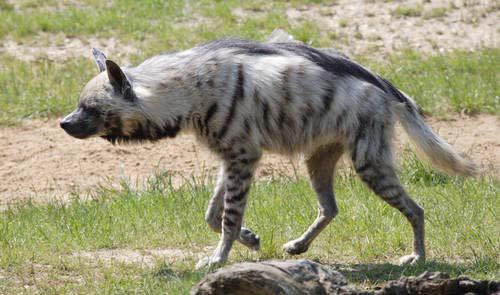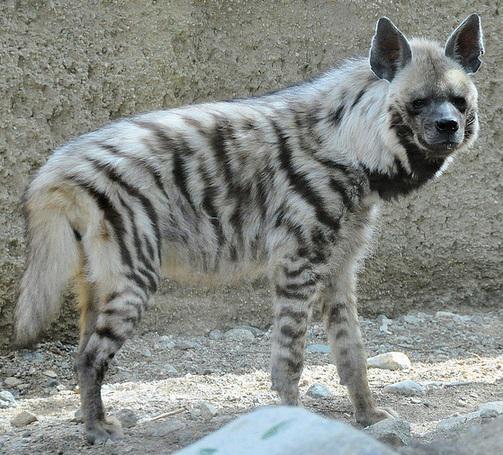The first image is the image on the left, the second image is the image on the right. Examine the images to the left and right. Is the description "Two hyenas are standing and facing opposite each other." accurate? Answer yes or no. Yes. The first image is the image on the left, the second image is the image on the right. Given the left and right images, does the statement "1 dog has a paw that is not touching the ground." hold true? Answer yes or no. Yes. 